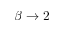<formula> <loc_0><loc_0><loc_500><loc_500>\beta \rightarrow 2</formula> 